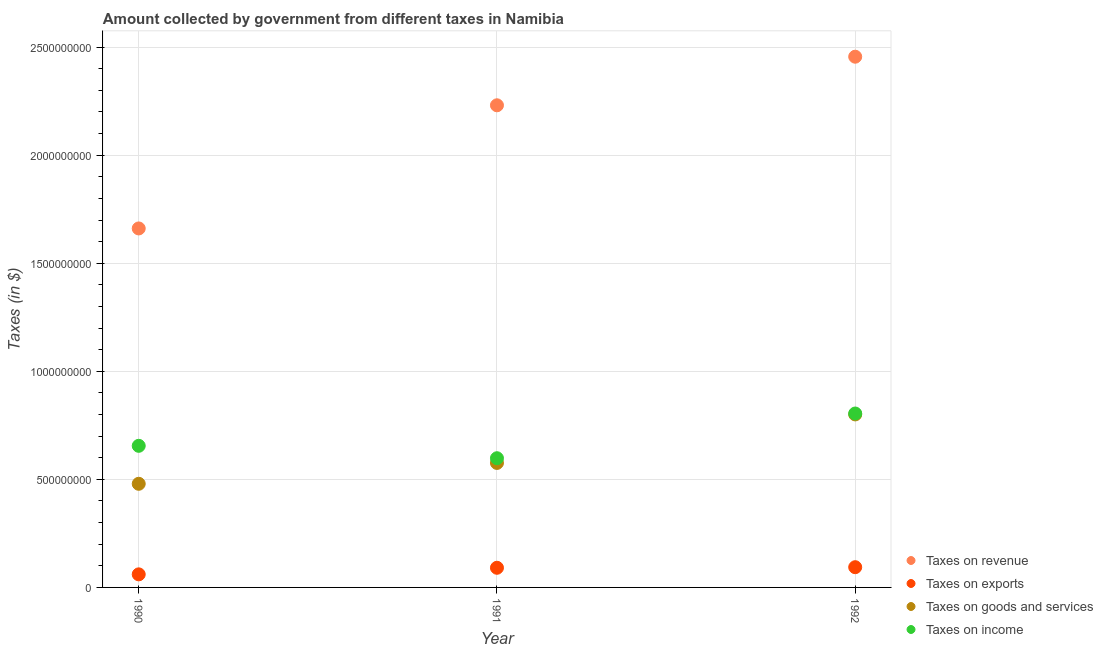How many different coloured dotlines are there?
Provide a succinct answer. 4. Is the number of dotlines equal to the number of legend labels?
Provide a succinct answer. Yes. What is the amount collected as tax on goods in 1990?
Offer a very short reply. 4.80e+08. Across all years, what is the maximum amount collected as tax on revenue?
Provide a succinct answer. 2.46e+09. Across all years, what is the minimum amount collected as tax on exports?
Provide a succinct answer. 6.05e+07. In which year was the amount collected as tax on revenue maximum?
Provide a succinct answer. 1992. What is the total amount collected as tax on goods in the graph?
Your response must be concise. 1.86e+09. What is the difference between the amount collected as tax on exports in 1990 and that in 1992?
Give a very brief answer. -3.31e+07. What is the difference between the amount collected as tax on goods in 1990 and the amount collected as tax on income in 1991?
Your response must be concise. -1.18e+08. What is the average amount collected as tax on revenue per year?
Your answer should be compact. 2.12e+09. In the year 1992, what is the difference between the amount collected as tax on goods and amount collected as tax on income?
Your answer should be very brief. -4.20e+06. What is the ratio of the amount collected as tax on revenue in 1990 to that in 1991?
Give a very brief answer. 0.74. Is the amount collected as tax on revenue in 1990 less than that in 1991?
Offer a very short reply. Yes. Is the difference between the amount collected as tax on income in 1991 and 1992 greater than the difference between the amount collected as tax on revenue in 1991 and 1992?
Your response must be concise. Yes. What is the difference between the highest and the second highest amount collected as tax on goods?
Make the answer very short. 2.24e+08. What is the difference between the highest and the lowest amount collected as tax on revenue?
Your answer should be compact. 7.95e+08. In how many years, is the amount collected as tax on exports greater than the average amount collected as tax on exports taken over all years?
Give a very brief answer. 2. Is it the case that in every year, the sum of the amount collected as tax on revenue and amount collected as tax on exports is greater than the amount collected as tax on goods?
Offer a very short reply. Yes. Does the amount collected as tax on goods monotonically increase over the years?
Offer a very short reply. Yes. Is the amount collected as tax on revenue strictly greater than the amount collected as tax on income over the years?
Ensure brevity in your answer.  Yes. How many dotlines are there?
Keep it short and to the point. 4. How many years are there in the graph?
Ensure brevity in your answer.  3. What is the difference between two consecutive major ticks on the Y-axis?
Your answer should be very brief. 5.00e+08. Are the values on the major ticks of Y-axis written in scientific E-notation?
Your answer should be compact. No. Does the graph contain any zero values?
Offer a terse response. No. Where does the legend appear in the graph?
Provide a short and direct response. Bottom right. How are the legend labels stacked?
Your answer should be compact. Vertical. What is the title of the graph?
Make the answer very short. Amount collected by government from different taxes in Namibia. What is the label or title of the X-axis?
Keep it short and to the point. Year. What is the label or title of the Y-axis?
Offer a terse response. Taxes (in $). What is the Taxes (in $) in Taxes on revenue in 1990?
Your answer should be compact. 1.66e+09. What is the Taxes (in $) of Taxes on exports in 1990?
Provide a succinct answer. 6.05e+07. What is the Taxes (in $) in Taxes on goods and services in 1990?
Make the answer very short. 4.80e+08. What is the Taxes (in $) of Taxes on income in 1990?
Your answer should be compact. 6.55e+08. What is the Taxes (in $) in Taxes on revenue in 1991?
Ensure brevity in your answer.  2.23e+09. What is the Taxes (in $) of Taxes on exports in 1991?
Your answer should be very brief. 9.09e+07. What is the Taxes (in $) in Taxes on goods and services in 1991?
Ensure brevity in your answer.  5.76e+08. What is the Taxes (in $) in Taxes on income in 1991?
Make the answer very short. 5.98e+08. What is the Taxes (in $) in Taxes on revenue in 1992?
Offer a very short reply. 2.46e+09. What is the Taxes (in $) in Taxes on exports in 1992?
Provide a succinct answer. 9.36e+07. What is the Taxes (in $) in Taxes on goods and services in 1992?
Your answer should be compact. 8.00e+08. What is the Taxes (in $) in Taxes on income in 1992?
Offer a very short reply. 8.05e+08. Across all years, what is the maximum Taxes (in $) in Taxes on revenue?
Your answer should be compact. 2.46e+09. Across all years, what is the maximum Taxes (in $) of Taxes on exports?
Your answer should be very brief. 9.36e+07. Across all years, what is the maximum Taxes (in $) of Taxes on goods and services?
Make the answer very short. 8.00e+08. Across all years, what is the maximum Taxes (in $) in Taxes on income?
Provide a succinct answer. 8.05e+08. Across all years, what is the minimum Taxes (in $) in Taxes on revenue?
Offer a very short reply. 1.66e+09. Across all years, what is the minimum Taxes (in $) in Taxes on exports?
Give a very brief answer. 6.05e+07. Across all years, what is the minimum Taxes (in $) of Taxes on goods and services?
Provide a succinct answer. 4.80e+08. Across all years, what is the minimum Taxes (in $) in Taxes on income?
Offer a terse response. 5.98e+08. What is the total Taxes (in $) of Taxes on revenue in the graph?
Your answer should be compact. 6.35e+09. What is the total Taxes (in $) in Taxes on exports in the graph?
Your answer should be very brief. 2.45e+08. What is the total Taxes (in $) of Taxes on goods and services in the graph?
Offer a very short reply. 1.86e+09. What is the total Taxes (in $) of Taxes on income in the graph?
Offer a very short reply. 2.06e+09. What is the difference between the Taxes (in $) of Taxes on revenue in 1990 and that in 1991?
Your answer should be very brief. -5.70e+08. What is the difference between the Taxes (in $) in Taxes on exports in 1990 and that in 1991?
Make the answer very short. -3.04e+07. What is the difference between the Taxes (in $) of Taxes on goods and services in 1990 and that in 1991?
Your response must be concise. -9.65e+07. What is the difference between the Taxes (in $) in Taxes on income in 1990 and that in 1991?
Your response must be concise. 5.74e+07. What is the difference between the Taxes (in $) of Taxes on revenue in 1990 and that in 1992?
Your answer should be compact. -7.95e+08. What is the difference between the Taxes (in $) of Taxes on exports in 1990 and that in 1992?
Give a very brief answer. -3.31e+07. What is the difference between the Taxes (in $) of Taxes on goods and services in 1990 and that in 1992?
Offer a very short reply. -3.21e+08. What is the difference between the Taxes (in $) of Taxes on income in 1990 and that in 1992?
Offer a very short reply. -1.50e+08. What is the difference between the Taxes (in $) in Taxes on revenue in 1991 and that in 1992?
Offer a terse response. -2.25e+08. What is the difference between the Taxes (in $) in Taxes on exports in 1991 and that in 1992?
Provide a succinct answer. -2.70e+06. What is the difference between the Taxes (in $) in Taxes on goods and services in 1991 and that in 1992?
Make the answer very short. -2.24e+08. What is the difference between the Taxes (in $) of Taxes on income in 1991 and that in 1992?
Your answer should be compact. -2.07e+08. What is the difference between the Taxes (in $) in Taxes on revenue in 1990 and the Taxes (in $) in Taxes on exports in 1991?
Provide a succinct answer. 1.57e+09. What is the difference between the Taxes (in $) in Taxes on revenue in 1990 and the Taxes (in $) in Taxes on goods and services in 1991?
Provide a succinct answer. 1.08e+09. What is the difference between the Taxes (in $) in Taxes on revenue in 1990 and the Taxes (in $) in Taxes on income in 1991?
Your answer should be compact. 1.06e+09. What is the difference between the Taxes (in $) of Taxes on exports in 1990 and the Taxes (in $) of Taxes on goods and services in 1991?
Ensure brevity in your answer.  -5.16e+08. What is the difference between the Taxes (in $) of Taxes on exports in 1990 and the Taxes (in $) of Taxes on income in 1991?
Your response must be concise. -5.37e+08. What is the difference between the Taxes (in $) in Taxes on goods and services in 1990 and the Taxes (in $) in Taxes on income in 1991?
Make the answer very short. -1.18e+08. What is the difference between the Taxes (in $) of Taxes on revenue in 1990 and the Taxes (in $) of Taxes on exports in 1992?
Make the answer very short. 1.57e+09. What is the difference between the Taxes (in $) in Taxes on revenue in 1990 and the Taxes (in $) in Taxes on goods and services in 1992?
Give a very brief answer. 8.60e+08. What is the difference between the Taxes (in $) of Taxes on revenue in 1990 and the Taxes (in $) of Taxes on income in 1992?
Make the answer very short. 8.56e+08. What is the difference between the Taxes (in $) of Taxes on exports in 1990 and the Taxes (in $) of Taxes on goods and services in 1992?
Give a very brief answer. -7.40e+08. What is the difference between the Taxes (in $) in Taxes on exports in 1990 and the Taxes (in $) in Taxes on income in 1992?
Your answer should be compact. -7.44e+08. What is the difference between the Taxes (in $) in Taxes on goods and services in 1990 and the Taxes (in $) in Taxes on income in 1992?
Provide a succinct answer. -3.25e+08. What is the difference between the Taxes (in $) of Taxes on revenue in 1991 and the Taxes (in $) of Taxes on exports in 1992?
Offer a terse response. 2.14e+09. What is the difference between the Taxes (in $) in Taxes on revenue in 1991 and the Taxes (in $) in Taxes on goods and services in 1992?
Your response must be concise. 1.43e+09. What is the difference between the Taxes (in $) in Taxes on revenue in 1991 and the Taxes (in $) in Taxes on income in 1992?
Offer a very short reply. 1.43e+09. What is the difference between the Taxes (in $) in Taxes on exports in 1991 and the Taxes (in $) in Taxes on goods and services in 1992?
Your answer should be very brief. -7.10e+08. What is the difference between the Taxes (in $) of Taxes on exports in 1991 and the Taxes (in $) of Taxes on income in 1992?
Keep it short and to the point. -7.14e+08. What is the difference between the Taxes (in $) in Taxes on goods and services in 1991 and the Taxes (in $) in Taxes on income in 1992?
Ensure brevity in your answer.  -2.29e+08. What is the average Taxes (in $) of Taxes on revenue per year?
Ensure brevity in your answer.  2.12e+09. What is the average Taxes (in $) of Taxes on exports per year?
Your response must be concise. 8.17e+07. What is the average Taxes (in $) in Taxes on goods and services per year?
Your answer should be very brief. 6.19e+08. What is the average Taxes (in $) of Taxes on income per year?
Ensure brevity in your answer.  6.86e+08. In the year 1990, what is the difference between the Taxes (in $) of Taxes on revenue and Taxes (in $) of Taxes on exports?
Your response must be concise. 1.60e+09. In the year 1990, what is the difference between the Taxes (in $) of Taxes on revenue and Taxes (in $) of Taxes on goods and services?
Give a very brief answer. 1.18e+09. In the year 1990, what is the difference between the Taxes (in $) in Taxes on revenue and Taxes (in $) in Taxes on income?
Offer a very short reply. 1.01e+09. In the year 1990, what is the difference between the Taxes (in $) of Taxes on exports and Taxes (in $) of Taxes on goods and services?
Offer a very short reply. -4.19e+08. In the year 1990, what is the difference between the Taxes (in $) of Taxes on exports and Taxes (in $) of Taxes on income?
Make the answer very short. -5.95e+08. In the year 1990, what is the difference between the Taxes (in $) of Taxes on goods and services and Taxes (in $) of Taxes on income?
Offer a terse response. -1.76e+08. In the year 1991, what is the difference between the Taxes (in $) of Taxes on revenue and Taxes (in $) of Taxes on exports?
Give a very brief answer. 2.14e+09. In the year 1991, what is the difference between the Taxes (in $) in Taxes on revenue and Taxes (in $) in Taxes on goods and services?
Your response must be concise. 1.65e+09. In the year 1991, what is the difference between the Taxes (in $) in Taxes on revenue and Taxes (in $) in Taxes on income?
Provide a short and direct response. 1.63e+09. In the year 1991, what is the difference between the Taxes (in $) in Taxes on exports and Taxes (in $) in Taxes on goods and services?
Keep it short and to the point. -4.85e+08. In the year 1991, what is the difference between the Taxes (in $) in Taxes on exports and Taxes (in $) in Taxes on income?
Keep it short and to the point. -5.07e+08. In the year 1991, what is the difference between the Taxes (in $) of Taxes on goods and services and Taxes (in $) of Taxes on income?
Keep it short and to the point. -2.18e+07. In the year 1992, what is the difference between the Taxes (in $) in Taxes on revenue and Taxes (in $) in Taxes on exports?
Your answer should be very brief. 2.36e+09. In the year 1992, what is the difference between the Taxes (in $) in Taxes on revenue and Taxes (in $) in Taxes on goods and services?
Make the answer very short. 1.66e+09. In the year 1992, what is the difference between the Taxes (in $) of Taxes on revenue and Taxes (in $) of Taxes on income?
Keep it short and to the point. 1.65e+09. In the year 1992, what is the difference between the Taxes (in $) of Taxes on exports and Taxes (in $) of Taxes on goods and services?
Your answer should be very brief. -7.07e+08. In the year 1992, what is the difference between the Taxes (in $) in Taxes on exports and Taxes (in $) in Taxes on income?
Your answer should be very brief. -7.11e+08. In the year 1992, what is the difference between the Taxes (in $) of Taxes on goods and services and Taxes (in $) of Taxes on income?
Offer a very short reply. -4.20e+06. What is the ratio of the Taxes (in $) in Taxes on revenue in 1990 to that in 1991?
Give a very brief answer. 0.74. What is the ratio of the Taxes (in $) in Taxes on exports in 1990 to that in 1991?
Give a very brief answer. 0.67. What is the ratio of the Taxes (in $) of Taxes on goods and services in 1990 to that in 1991?
Provide a short and direct response. 0.83. What is the ratio of the Taxes (in $) of Taxes on income in 1990 to that in 1991?
Provide a succinct answer. 1.1. What is the ratio of the Taxes (in $) of Taxes on revenue in 1990 to that in 1992?
Keep it short and to the point. 0.68. What is the ratio of the Taxes (in $) of Taxes on exports in 1990 to that in 1992?
Your response must be concise. 0.65. What is the ratio of the Taxes (in $) of Taxes on goods and services in 1990 to that in 1992?
Offer a terse response. 0.6. What is the ratio of the Taxes (in $) of Taxes on income in 1990 to that in 1992?
Give a very brief answer. 0.81. What is the ratio of the Taxes (in $) of Taxes on revenue in 1991 to that in 1992?
Your response must be concise. 0.91. What is the ratio of the Taxes (in $) of Taxes on exports in 1991 to that in 1992?
Give a very brief answer. 0.97. What is the ratio of the Taxes (in $) of Taxes on goods and services in 1991 to that in 1992?
Make the answer very short. 0.72. What is the ratio of the Taxes (in $) of Taxes on income in 1991 to that in 1992?
Keep it short and to the point. 0.74. What is the difference between the highest and the second highest Taxes (in $) in Taxes on revenue?
Provide a short and direct response. 2.25e+08. What is the difference between the highest and the second highest Taxes (in $) of Taxes on exports?
Ensure brevity in your answer.  2.70e+06. What is the difference between the highest and the second highest Taxes (in $) in Taxes on goods and services?
Your answer should be very brief. 2.24e+08. What is the difference between the highest and the second highest Taxes (in $) in Taxes on income?
Your answer should be compact. 1.50e+08. What is the difference between the highest and the lowest Taxes (in $) in Taxes on revenue?
Your answer should be compact. 7.95e+08. What is the difference between the highest and the lowest Taxes (in $) in Taxes on exports?
Ensure brevity in your answer.  3.31e+07. What is the difference between the highest and the lowest Taxes (in $) of Taxes on goods and services?
Provide a short and direct response. 3.21e+08. What is the difference between the highest and the lowest Taxes (in $) in Taxes on income?
Ensure brevity in your answer.  2.07e+08. 